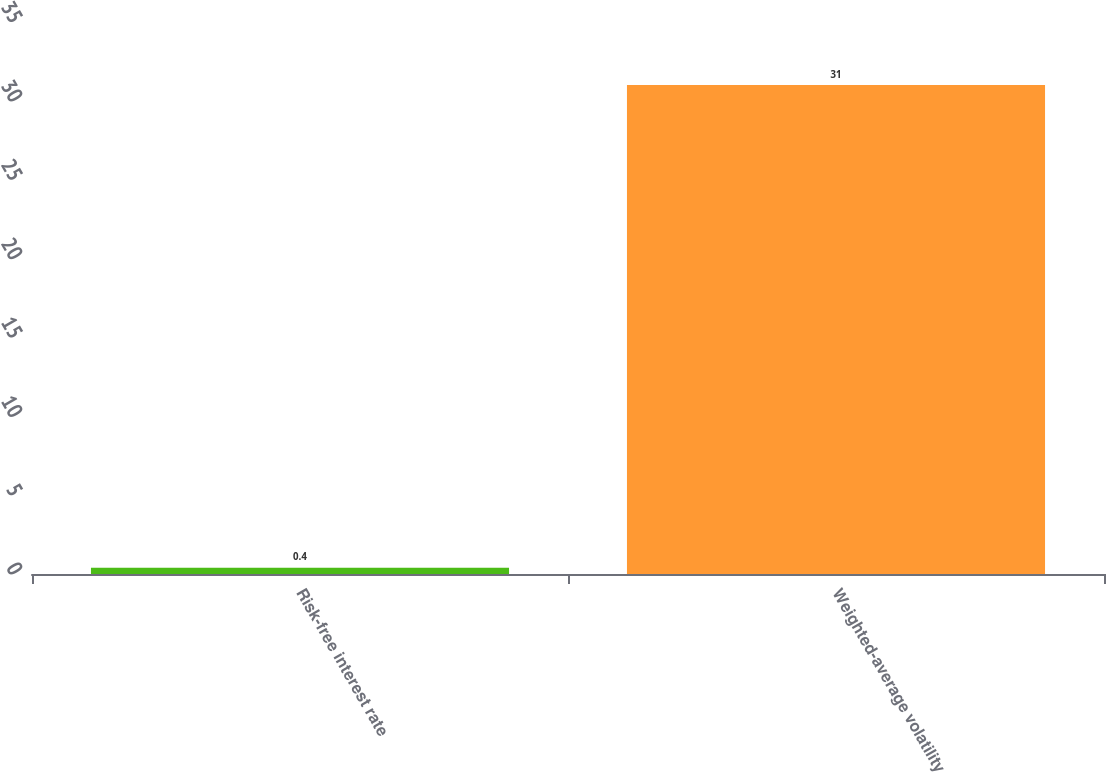Convert chart to OTSL. <chart><loc_0><loc_0><loc_500><loc_500><bar_chart><fcel>Risk-free interest rate<fcel>Weighted-average volatility<nl><fcel>0.4<fcel>31<nl></chart> 